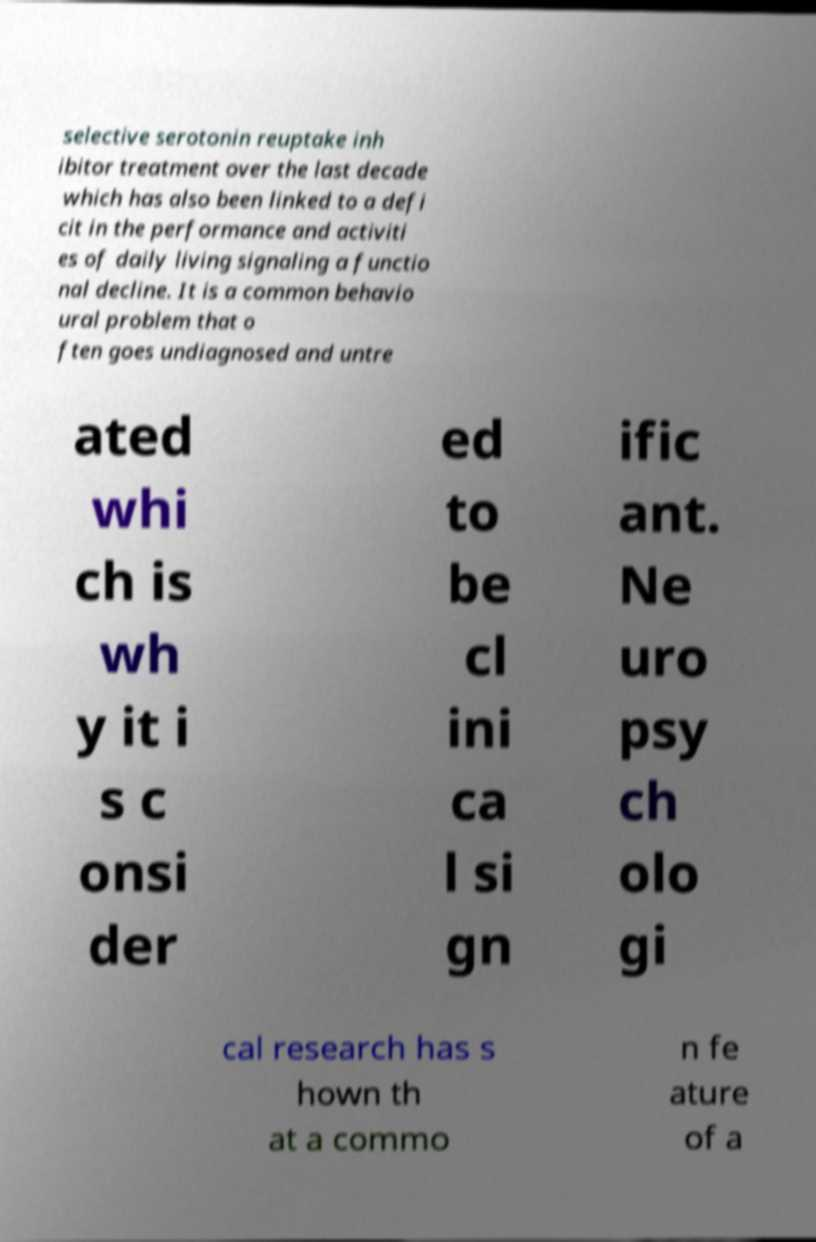Could you assist in decoding the text presented in this image and type it out clearly? selective serotonin reuptake inh ibitor treatment over the last decade which has also been linked to a defi cit in the performance and activiti es of daily living signaling a functio nal decline. It is a common behavio ural problem that o ften goes undiagnosed and untre ated whi ch is wh y it i s c onsi der ed to be cl ini ca l si gn ific ant. Ne uro psy ch olo gi cal research has s hown th at a commo n fe ature of a 